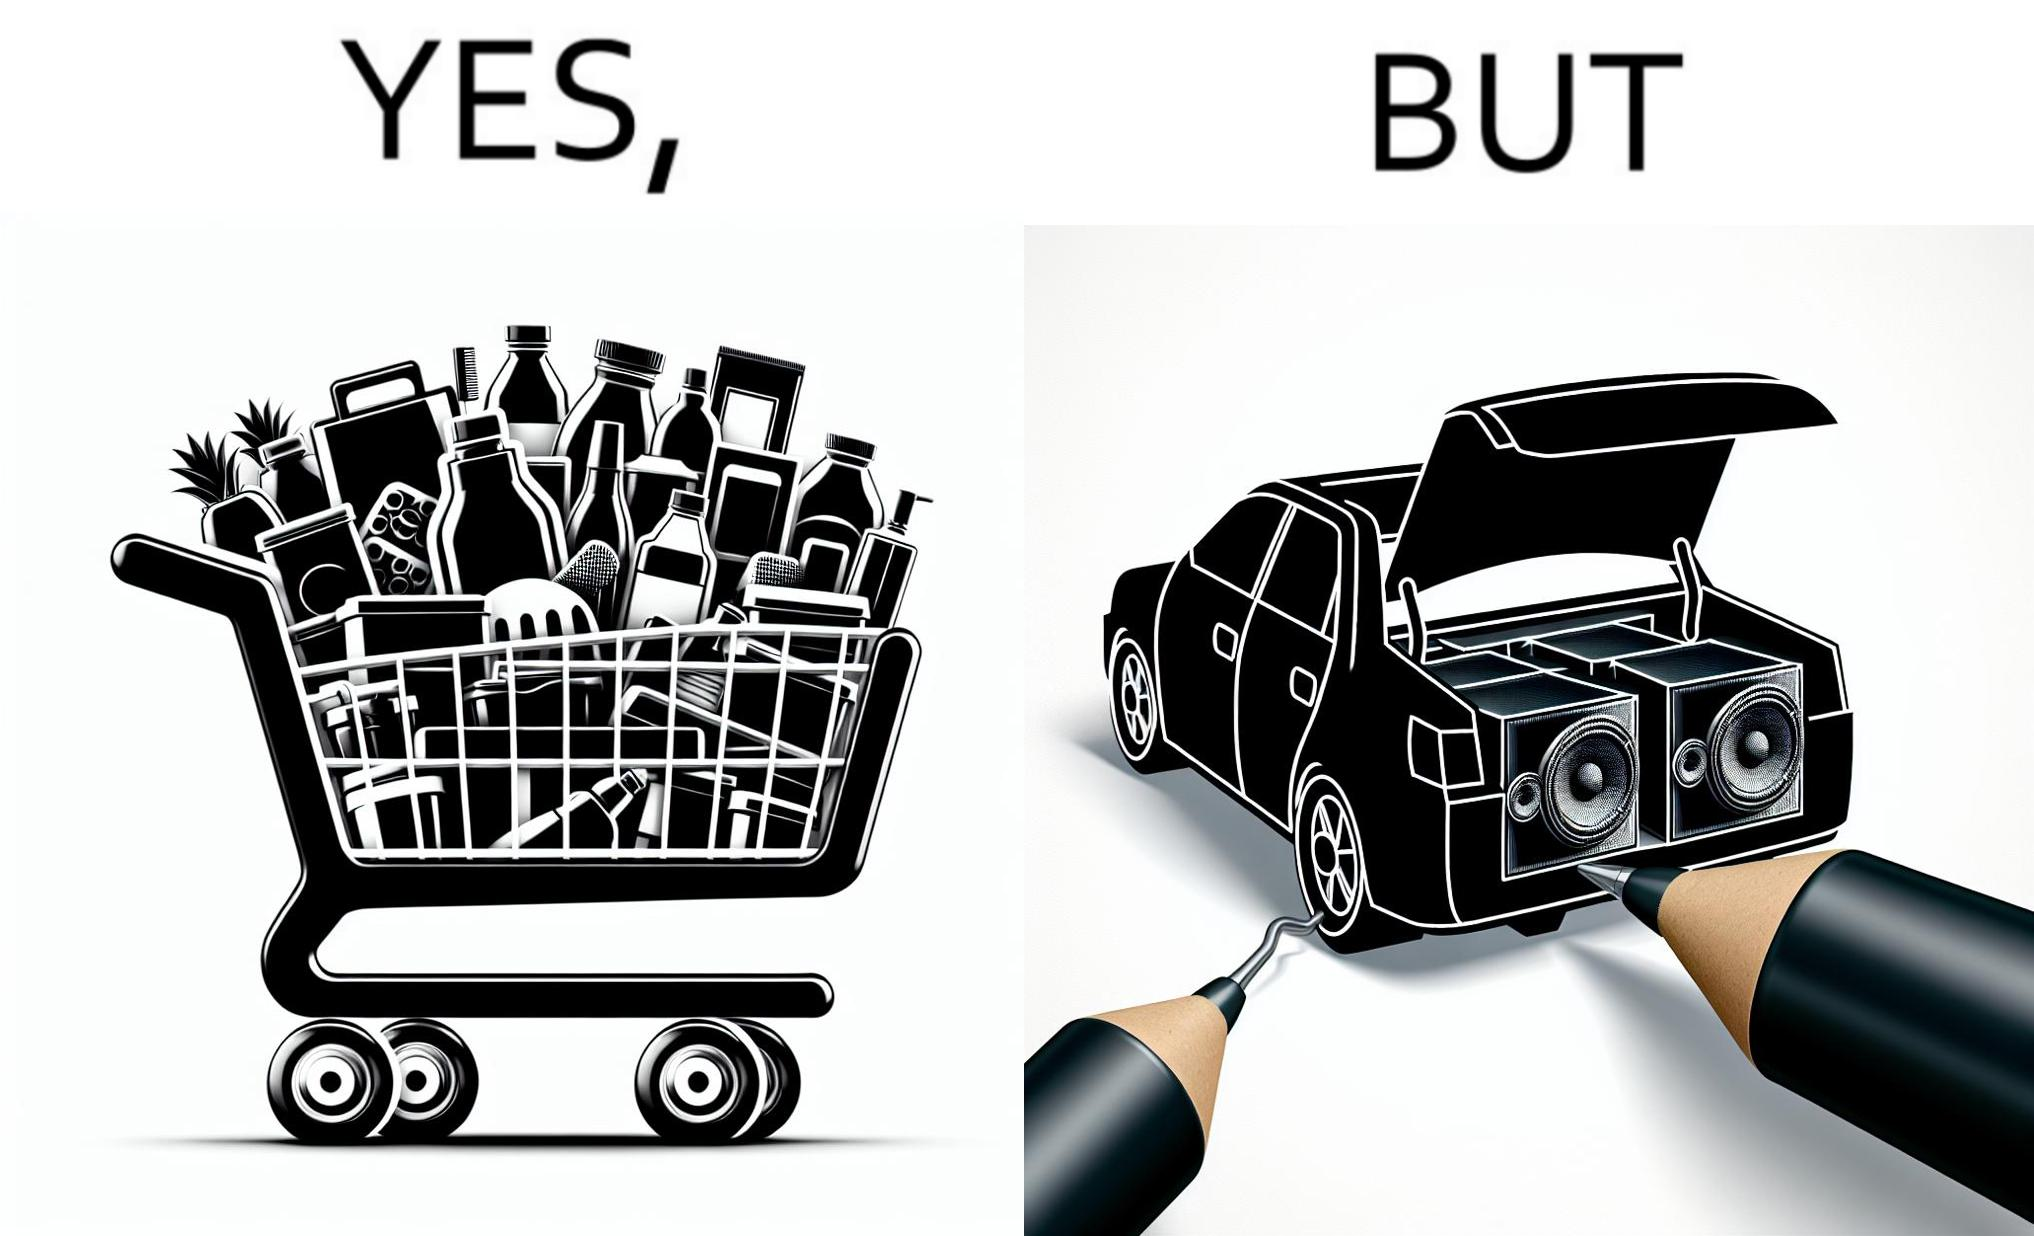Is this a satirical image? Yes, this image is satirical. 